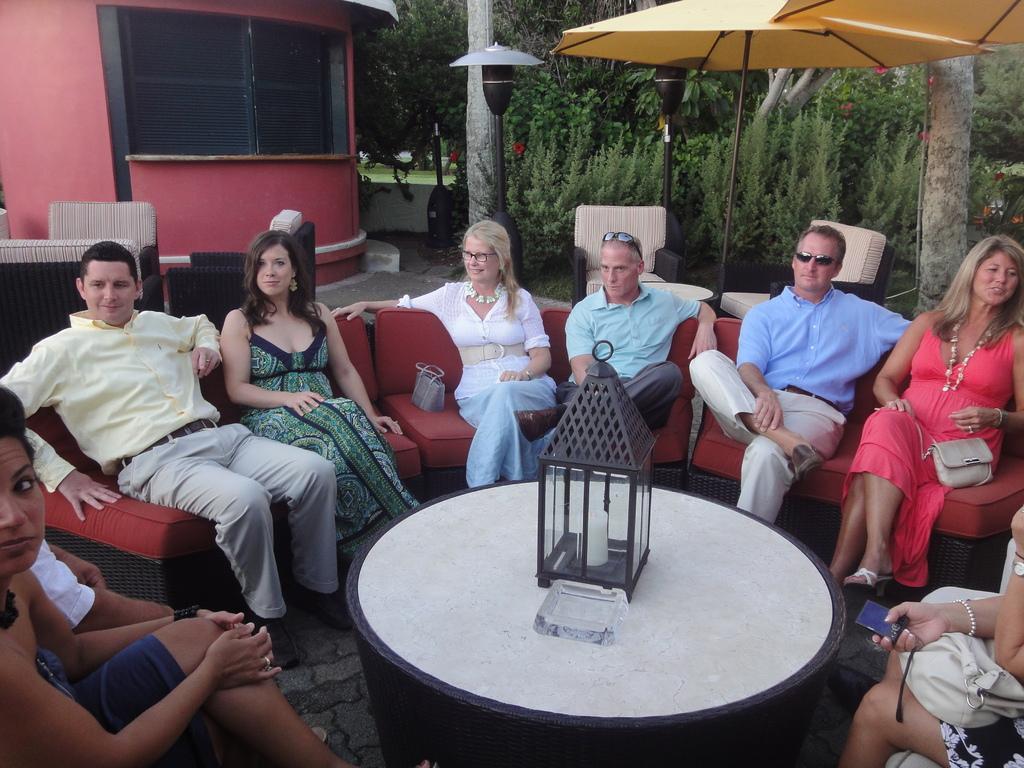Can you describe this image briefly? There are four ladies and three men are sitting on a red color sofa. In front of them there is a table. On that table there is an object. Inside that object there is a candle. Behind them there are some trees, lamps. We can also see red color building. 